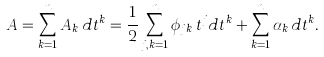Convert formula to latex. <formula><loc_0><loc_0><loc_500><loc_500>A = \sum _ { k = 1 } ^ { n } A _ { k } \, d t ^ { k } = \frac { 1 } { 2 } \sum _ { j , k = 1 } ^ { n } \phi _ { j k } \, t ^ { j } d t ^ { k } + \sum _ { k = 1 } ^ { n } \alpha _ { k } \, d t ^ { k } .</formula> 